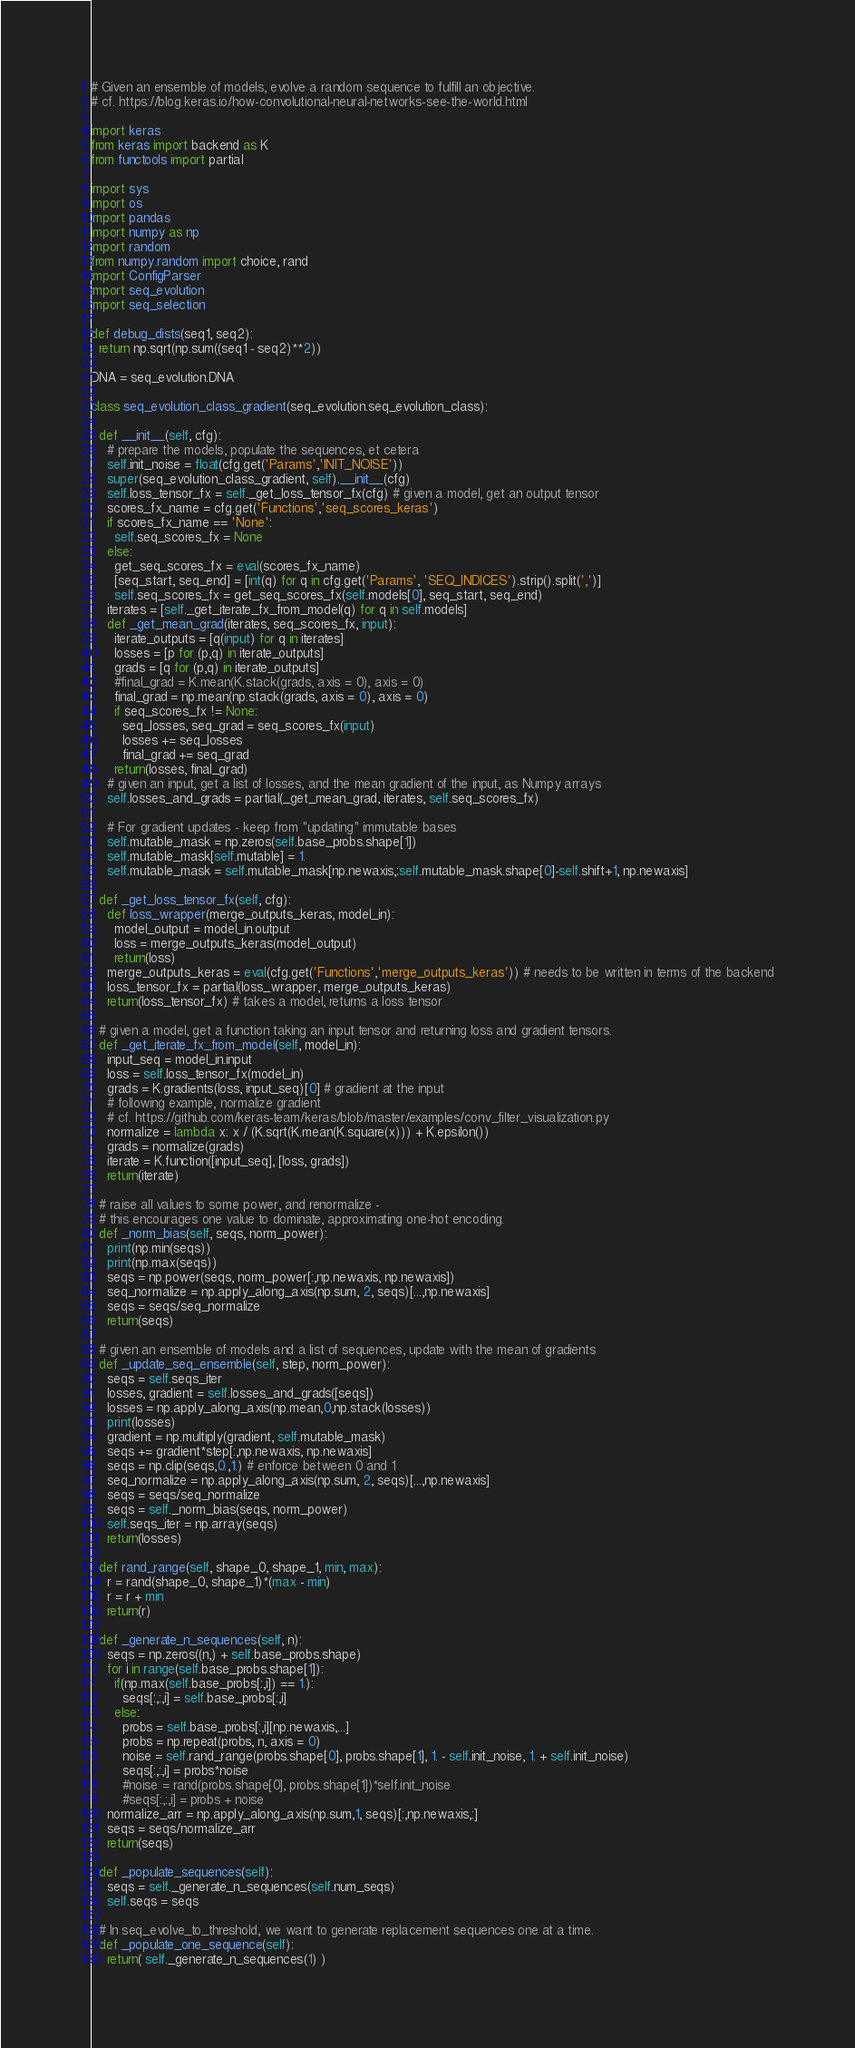<code> <loc_0><loc_0><loc_500><loc_500><_Python_># Given an ensemble of models, evolve a random sequence to fulfill an objective.
# cf. https://blog.keras.io/how-convolutional-neural-networks-see-the-world.html

import keras
from keras import backend as K
from functools import partial

import sys
import os
import pandas
import numpy as np
import random
from numpy.random import choice, rand
import ConfigParser
import seq_evolution
import seq_selection

def debug_dists(seq1, seq2):
  return np.sqrt(np.sum((seq1 - seq2)**2))

DNA = seq_evolution.DNA

class seq_evolution_class_gradient(seq_evolution.seq_evolution_class):

  def __init__(self, cfg):
    # prepare the models, populate the sequences, et cetera
    self.init_noise = float(cfg.get('Params','INIT_NOISE'))
    super(seq_evolution_class_gradient, self).__init__(cfg)
    self.loss_tensor_fx = self._get_loss_tensor_fx(cfg) # given a model, get an output tensor
    scores_fx_name = cfg.get('Functions','seq_scores_keras')
    if scores_fx_name == 'None':
      self.seq_scores_fx = None
    else:
      get_seq_scores_fx = eval(scores_fx_name)
      [seq_start, seq_end] = [int(q) for q in cfg.get('Params', 'SEQ_INDICES').strip().split(',')]
      self.seq_scores_fx = get_seq_scores_fx(self.models[0], seq_start, seq_end)
    iterates = [self._get_iterate_fx_from_model(q) for q in self.models]
    def _get_mean_grad(iterates, seq_scores_fx, input):
      iterate_outputs = [q(input) for q in iterates]
      losses = [p for (p,q) in iterate_outputs]
      grads = [q for (p,q) in iterate_outputs]
      #final_grad = K.mean(K.stack(grads, axis = 0), axis = 0)
      final_grad = np.mean(np.stack(grads, axis = 0), axis = 0)
      if seq_scores_fx != None:
        seq_losses, seq_grad = seq_scores_fx(input)
        losses += seq_losses
        final_grad += seq_grad
      return(losses, final_grad)
    # given an input, get a list of losses, and the mean gradient of the input, as Numpy arrays
    self.losses_and_grads = partial(_get_mean_grad, iterates, self.seq_scores_fx)

    # For gradient updates - keep from "updating" immutable bases
    self.mutable_mask = np.zeros(self.base_probs.shape[1])
    self.mutable_mask[self.mutable] = 1.
    self.mutable_mask = self.mutable_mask[np.newaxis,:self.mutable_mask.shape[0]-self.shift+1, np.newaxis]

  def _get_loss_tensor_fx(self, cfg):
    def loss_wrapper(merge_outputs_keras, model_in):
      model_output = model_in.output
      loss = merge_outputs_keras(model_output)
      return(loss)
    merge_outputs_keras = eval(cfg.get('Functions','merge_outputs_keras')) # needs to be written in terms of the backend
    loss_tensor_fx = partial(loss_wrapper, merge_outputs_keras)
    return(loss_tensor_fx) # takes a model, returns a loss tensor

  # given a model, get a function taking an input tensor and returning loss and gradient tensors.
  def _get_iterate_fx_from_model(self, model_in):
    input_seq = model_in.input
    loss = self.loss_tensor_fx(model_in)
    grads = K.gradients(loss, input_seq)[0] # gradient at the input
    # following example, normalize gradient
    # cf. https://github.com/keras-team/keras/blob/master/examples/conv_filter_visualization.py
    normalize = lambda x: x / (K.sqrt(K.mean(K.square(x))) + K.epsilon())
    grads = normalize(grads)
    iterate = K.function([input_seq], [loss, grads])
    return(iterate)

  # raise all values to some power, and renormalize -
  # this encourages one value to dominate, approximating one-hot encoding.
  def _norm_bias(self, seqs, norm_power):
    print(np.min(seqs))
    print(np.max(seqs))
    seqs = np.power(seqs, norm_power[:,np.newaxis, np.newaxis])
    seq_normalize = np.apply_along_axis(np.sum, 2, seqs)[...,np.newaxis]
    seqs = seqs/seq_normalize
    return(seqs)

  # given an ensemble of models and a list of sequences, update with the mean of gradients
  def _update_seq_ensemble(self, step, norm_power):
    seqs = self.seqs_iter
    losses, gradient = self.losses_and_grads([seqs])
    losses = np.apply_along_axis(np.mean,0,np.stack(losses))
    print(losses)
    gradient = np.multiply(gradient, self.mutable_mask)
    seqs += gradient*step[:,np.newaxis, np.newaxis]
    seqs = np.clip(seqs,0.,1.) # enforce between 0 and 1
    seq_normalize = np.apply_along_axis(np.sum, 2, seqs)[...,np.newaxis]
    seqs = seqs/seq_normalize
    seqs = self._norm_bias(seqs, norm_power)
    self.seqs_iter = np.array(seqs)
    return(losses)

  def rand_range(self, shape_0, shape_1, min, max):
    r = rand(shape_0, shape_1)*(max - min)
    r = r + min
    return(r)

  def _generate_n_sequences(self, n):
    seqs = np.zeros((n,) + self.base_probs.shape)
    for i in range(self.base_probs.shape[1]):
      if(np.max(self.base_probs[:,i]) == 1.):
        seqs[:,:,i] = self.base_probs[:,i]
      else:
        probs = self.base_probs[:,i][np.newaxis,...]
        probs = np.repeat(probs, n, axis = 0)
        noise = self.rand_range(probs.shape[0], probs.shape[1], 1. - self.init_noise, 1. + self.init_noise)
        seqs[:,:,i] = probs*noise
        #noise = rand(probs.shape[0], probs.shape[1])*self.init_noise
        #seqs[:,:,i] = probs + noise
    normalize_arr = np.apply_along_axis(np.sum,1, seqs)[:,np.newaxis,:]
    seqs = seqs/normalize_arr
    return(seqs)

  def _populate_sequences(self):
    seqs = self._generate_n_sequences(self.num_seqs)
    self.seqs = seqs

  # In seq_evolve_to_threshold, we want to generate replacement sequences one at a time.
  def _populate_one_sequence(self):
    return( self._generate_n_sequences(1) )
</code> 